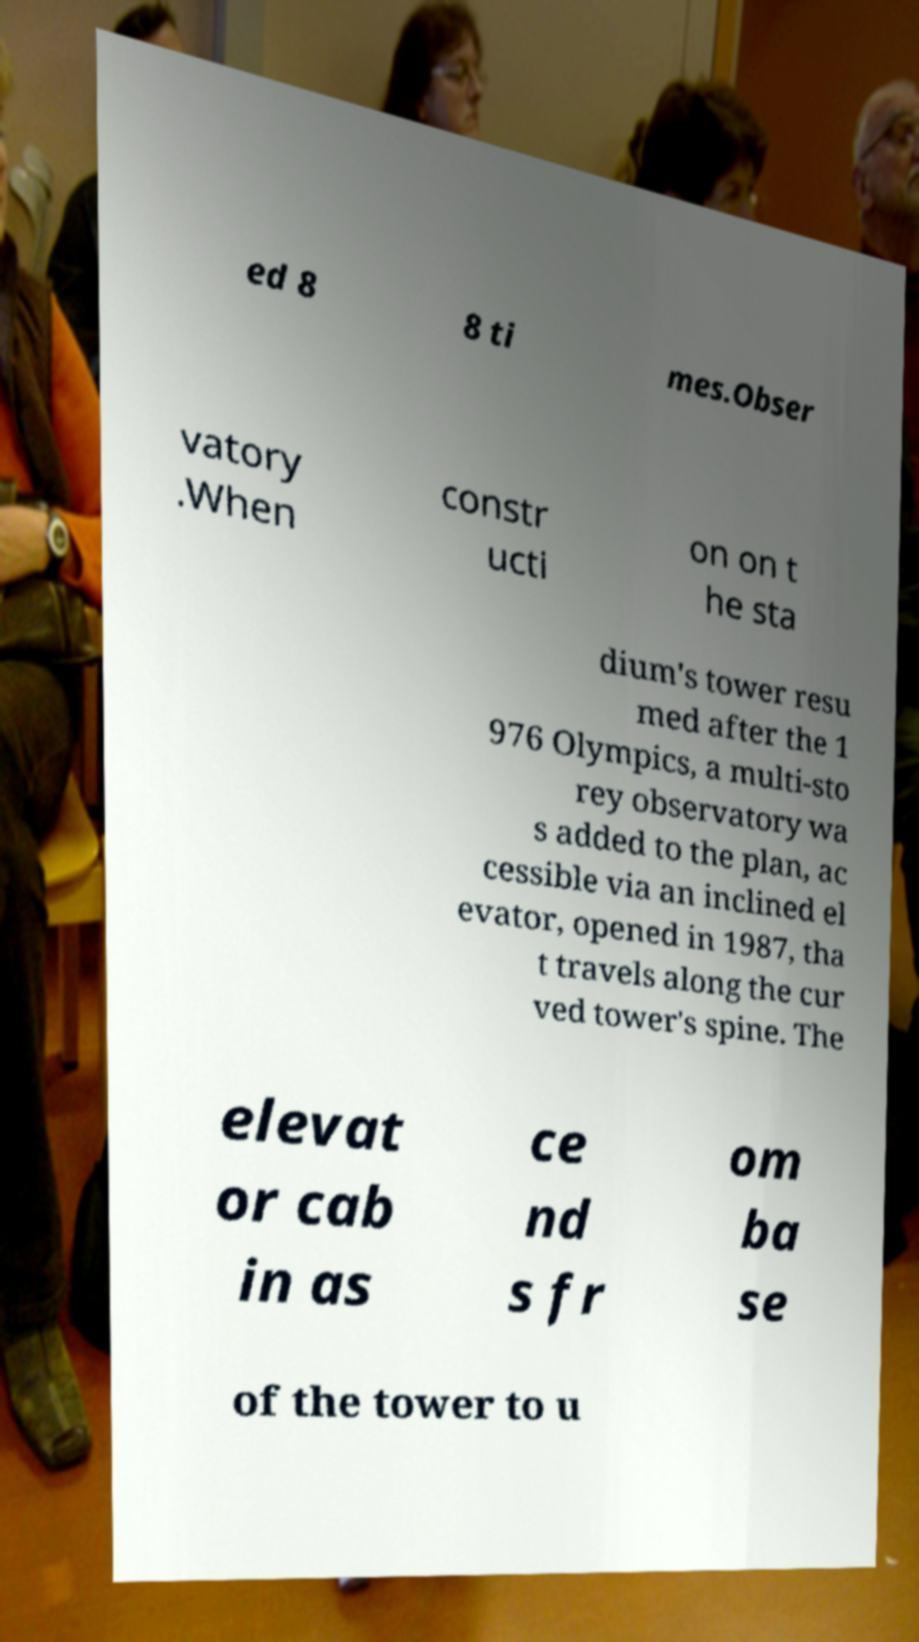Could you assist in decoding the text presented in this image and type it out clearly? ed 8 8 ti mes.Obser vatory .When constr ucti on on t he sta dium's tower resu med after the 1 976 Olympics, a multi-sto rey observatory wa s added to the plan, ac cessible via an inclined el evator, opened in 1987, tha t travels along the cur ved tower's spine. The elevat or cab in as ce nd s fr om ba se of the tower to u 